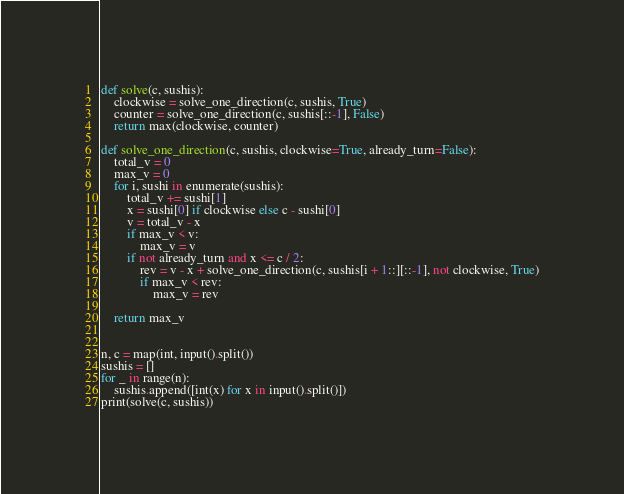<code> <loc_0><loc_0><loc_500><loc_500><_Python_>def solve(c, sushis):
    clockwise = solve_one_direction(c, sushis, True)
    counter = solve_one_direction(c, sushis[::-1], False)
    return max(clockwise, counter)

def solve_one_direction(c, sushis, clockwise=True, already_turn=False):
    total_v = 0
    max_v = 0
    for i, sushi in enumerate(sushis):
        total_v += sushi[1]
        x = sushi[0] if clockwise else c - sushi[0]
        v = total_v - x
        if max_v < v:
            max_v = v
        if not already_turn and x <= c / 2:
            rev = v - x + solve_one_direction(c, sushis[i + 1::][::-1], not clockwise, True)
            if max_v < rev:
                max_v = rev

    return max_v


n, c = map(int, input().split())
sushis = []
for _ in range(n):
    sushis.append([int(x) for x in input().split()])
print(solve(c, sushis))
</code> 